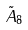Convert formula to latex. <formula><loc_0><loc_0><loc_500><loc_500>\tilde { A } _ { 8 }</formula> 